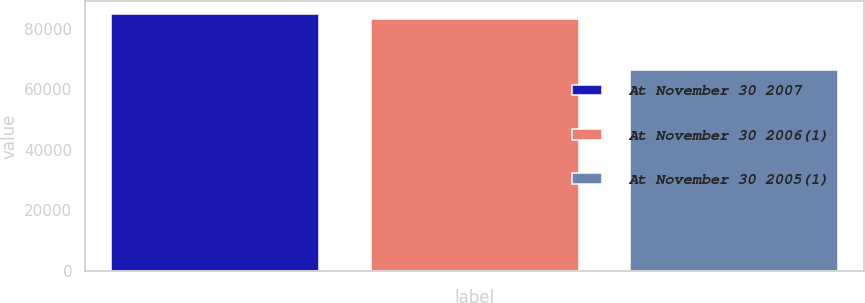Convert chart to OTSL. <chart><loc_0><loc_0><loc_500><loc_500><bar_chart><fcel>At November 30 2007<fcel>At November 30 2006(1)<fcel>At November 30 2005(1)<nl><fcel>84995.1<fcel>83315<fcel>66527<nl></chart> 